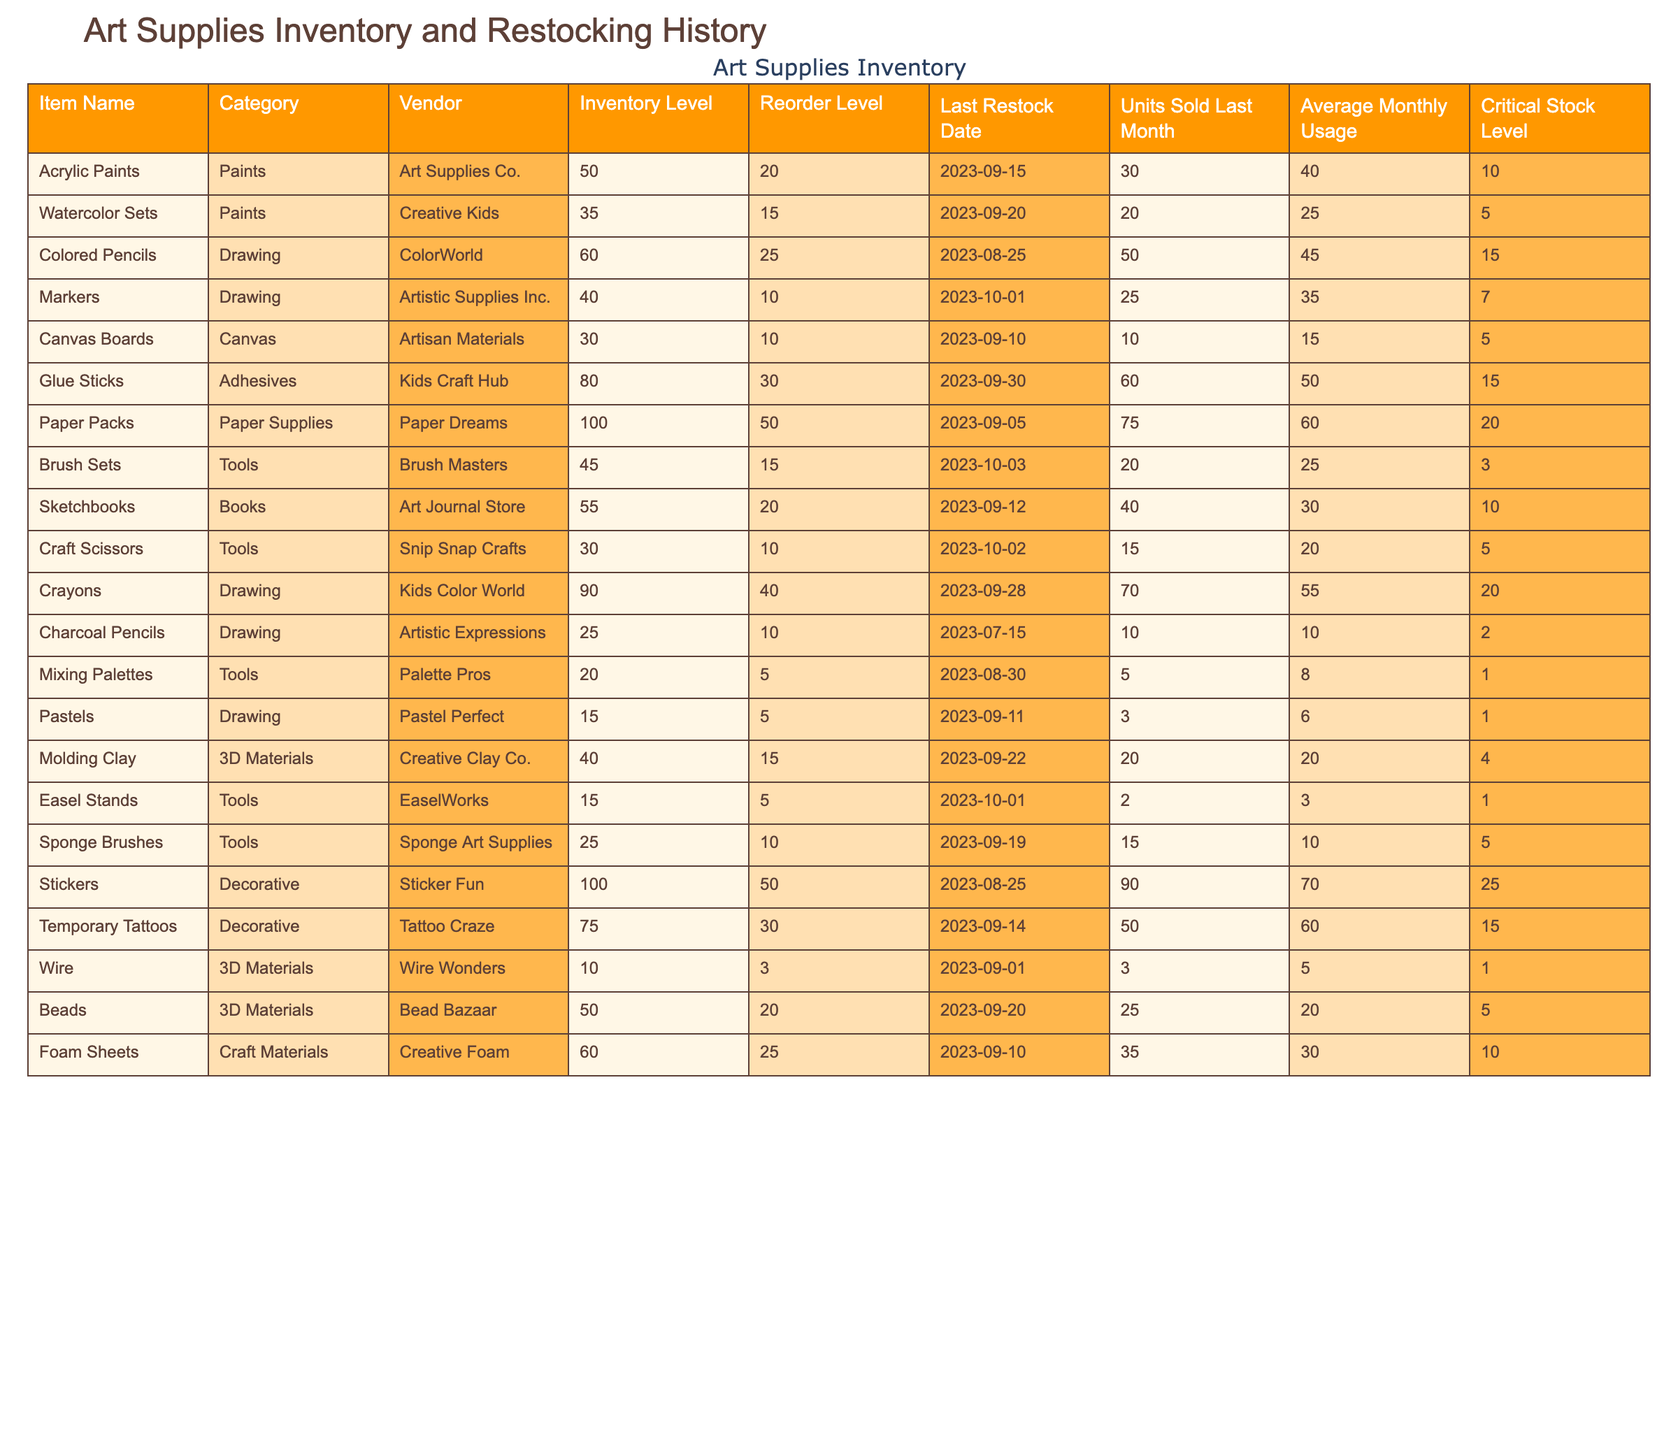What is the inventory level of Colored Pencils? The table shows the inventory level for each item. For Colored Pencils, the inventory level is listed as 60.
Answer: 60 Which item has the highest reorder level? By reviewing the reorder levels in the table, we see that the highest reorder level is for Stickers, which is 50.
Answer: Stickers Is the inventory level of Molding Clay above its critical stock level? The inventory level for Molding Clay is 40, and its critical stock level is 4. Since 40 is greater than 4, we can conclude that it is above the critical level.
Answer: Yes How many units of Glue Sticks were sold last month? The table lists the units sold last month for Glue Sticks as 60.
Answer: 60 What is the average monthly usage of Watercolor Sets? The average monthly usage for Watercolor Sets is directly listed in the table as 25.
Answer: 25 Which items are below their reorder level? To find the items below their reorder level, we compare the inventory levels with their reorder levels: Molding Clay (40 < 15), Easel Stands (15 < 5), and Mixing Palettes (20 < 5) are all below their reorder levels.
Answer: Molding Clay, Easel Stands, Mixing Palettes How many more units can be sold from the current inventory of Acrylic Paints before reaching the reorder level? The current inventory level of Acrylic Paints is 50 and the reorder level is 20. To find out how many more can be sold, we calculate 50 - 20 = 30.
Answer: 30 What is the total inventory of all paint-related items? Paint-related items are: Acrylic Paints (50), Watercolor Sets (35), and Crayons (90). Summing these gives 50 + 35 + 90 = 175.
Answer: 175 Do any items have an inventory level equal to their critical stock level? By checking the inventory and critical stock levels, only Charcoal Pencils have an inventory level (25) equal to its critical level (2).
Answer: No Which item has been restocked most recently? Referring to the Last Restock Date column, the most recent restock date is for Markers on 2023-10-01.
Answer: Markers If we combine the inventory levels of Tools, how many total items do we have? The Tools listed are Brush Sets (45), Craft Scissors (30), Mixing Palettes (20), Sponge Brushes (25), and Easel Stands (15). Adding these gives a total of 45 + 30 + 20 + 25 + 15 = 135.
Answer: 135 